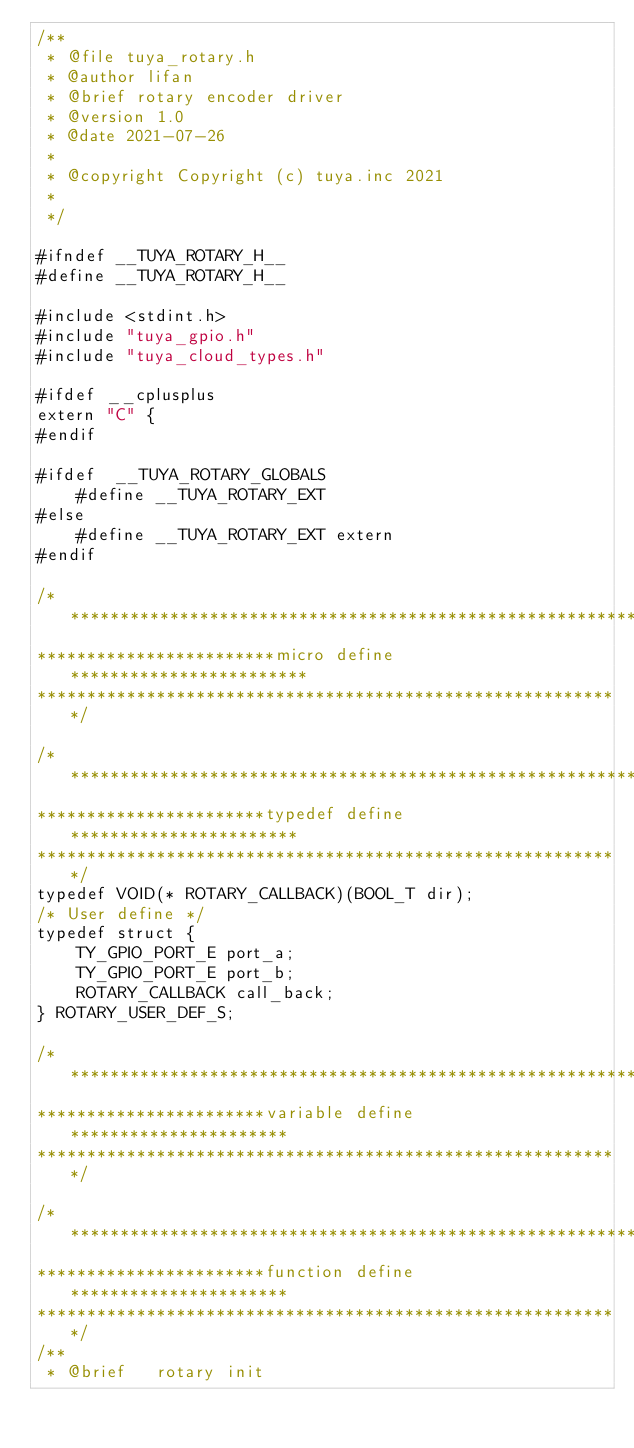Convert code to text. <code><loc_0><loc_0><loc_500><loc_500><_C_>/**
 * @file tuya_rotary.h
 * @author lifan
 * @brief rotary encoder driver
 * @version 1.0
 * @date 2021-07-26
 *
 * @copyright Copyright (c) tuya.inc 2021
 *
 */

#ifndef __TUYA_ROTARY_H__
#define __TUYA_ROTARY_H__

#include <stdint.h>
#include "tuya_gpio.h"
#include "tuya_cloud_types.h"

#ifdef __cplusplus
extern "C" {
#endif

#ifdef  __TUYA_ROTARY_GLOBALS
    #define __TUYA_ROTARY_EXT
#else
    #define __TUYA_ROTARY_EXT extern
#endif

/***********************************************************
************************micro define************************
***********************************************************/

/***********************************************************
***********************typedef define***********************
***********************************************************/
typedef VOID(* ROTARY_CALLBACK)(BOOL_T dir);
/* User define */
typedef struct {
    TY_GPIO_PORT_E port_a;
    TY_GPIO_PORT_E port_b;
    ROTARY_CALLBACK call_back;
} ROTARY_USER_DEF_S;

/***********************************************************
***********************variable define**********************
***********************************************************/

/***********************************************************
***********************function define**********************
***********************************************************/
/**
 * @brief   rotary init</code> 